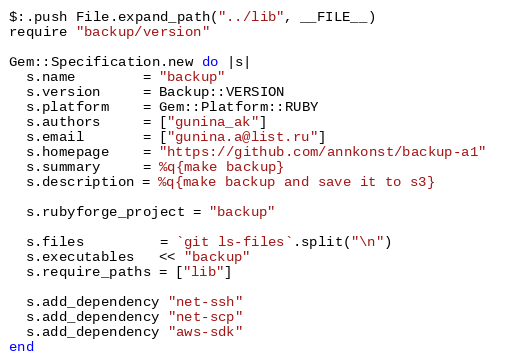Convert code to text. <code><loc_0><loc_0><loc_500><loc_500><_Ruby_>$:.push File.expand_path("../lib", __FILE__)  
require "backup/version"  

Gem::Specification.new do |s|  
  s.name        = "backup"  
  s.version     = Backup::VERSION  
  s.platform    = Gem::Platform::RUBY  
  s.authors     = ["gunina_ak"]  
  s.email       = ["gunina.a@list.ru"]  
  s.homepage    = "https://github.com/annkonst/backup-a1"  
  s.summary     = %q{make backup}  
  s.description = %q{make backup and save it to s3}  

  s.rubyforge_project = "backup"  

  s.files         = `git ls-files`.split("\n")   
  s.executables   << "backup"
  s.require_paths = ["lib"]  

  s.add_dependency "net-ssh"
  s.add_dependency "net-scp"
  s.add_dependency "aws-sdk"
end 
</code> 